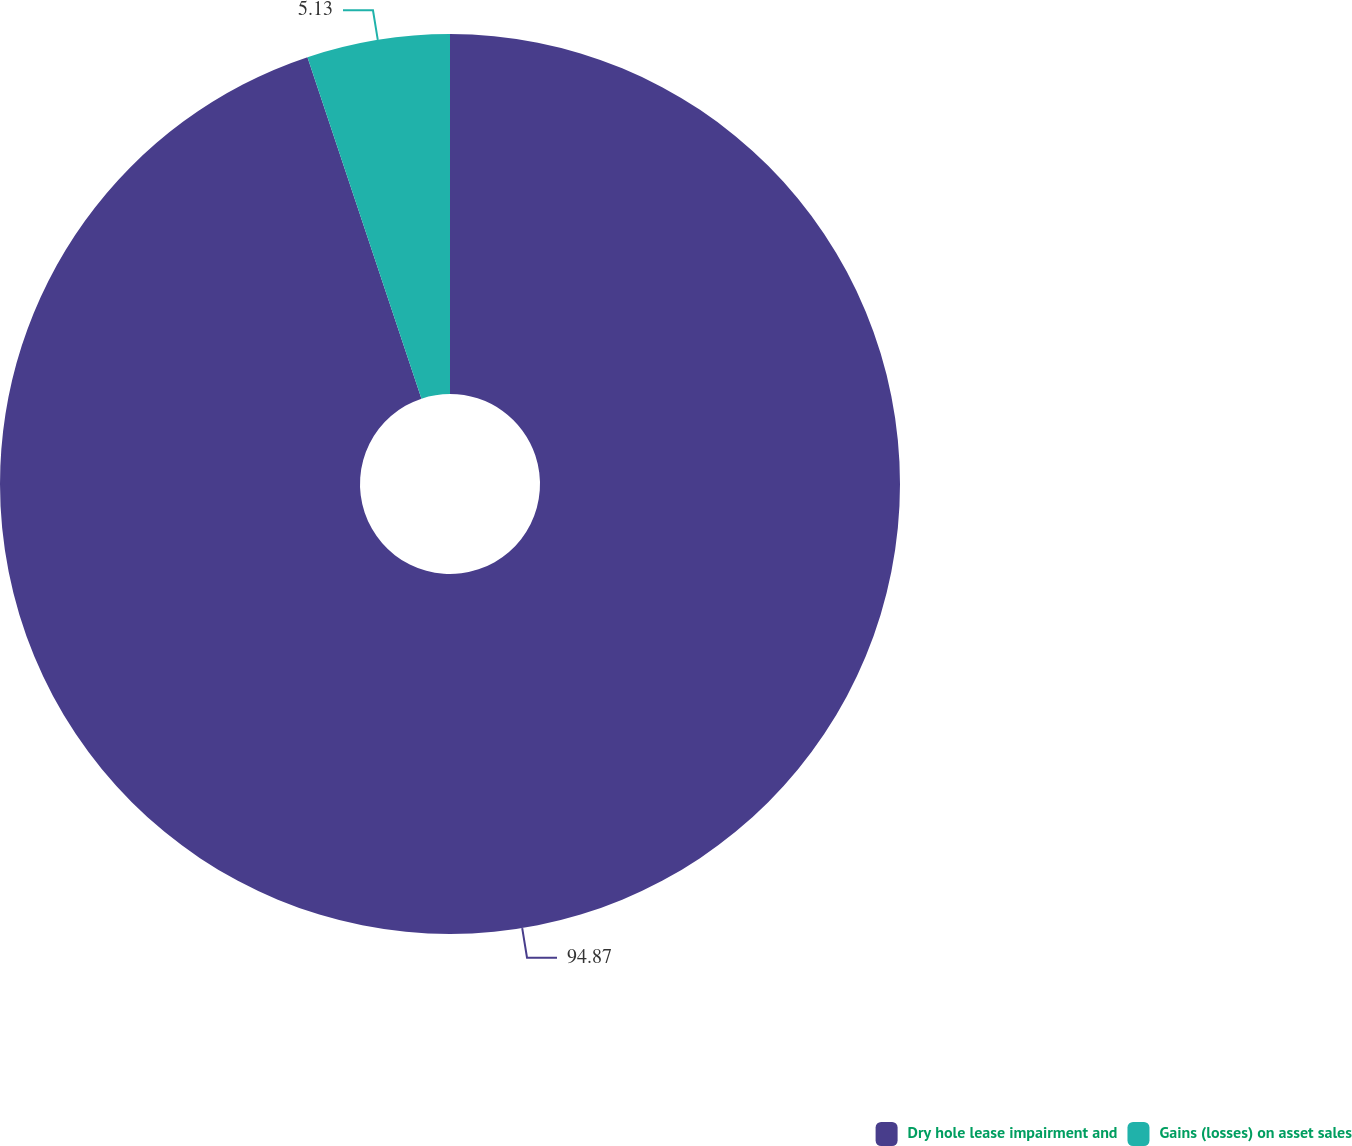Convert chart to OTSL. <chart><loc_0><loc_0><loc_500><loc_500><pie_chart><fcel>Dry hole lease impairment and<fcel>Gains (losses) on asset sales<nl><fcel>94.87%<fcel>5.13%<nl></chart> 